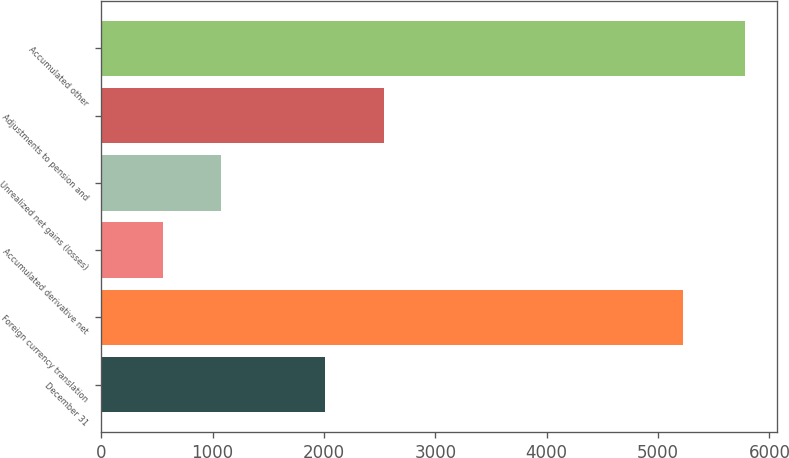Convert chart to OTSL. <chart><loc_0><loc_0><loc_500><loc_500><bar_chart><fcel>December 31<fcel>Foreign currency translation<fcel>Accumulated derivative net<fcel>Unrealized net gains (losses)<fcel>Adjustments to pension and<fcel>Accumulated other<nl><fcel>2014<fcel>5226<fcel>554<fcel>1076.3<fcel>2536.3<fcel>5777<nl></chart> 